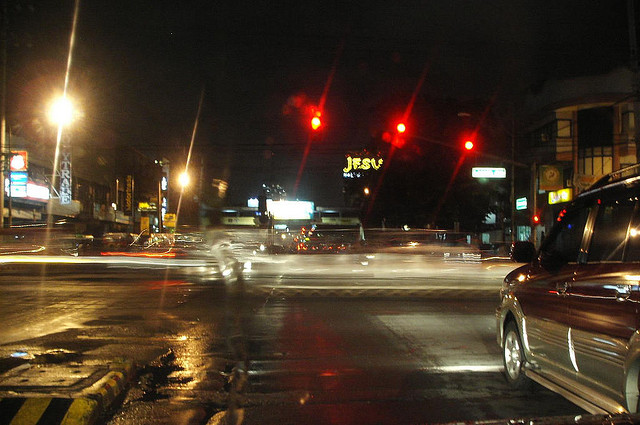Extract all visible text content from this image. JFSU 